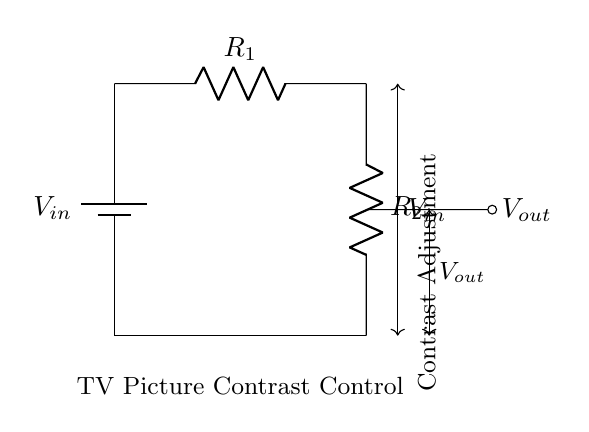What is the input voltage in the circuit? The input voltage, labeled as V_in, is the voltage supplied by the battery in the diagram.
Answer: V_in What are the two resistors used in this circuit? The circuit contains two resistors, labeled R_1 and R_2, which are essential for the voltage divider function.
Answer: R_1 and R_2 What is the output voltage taken from in this circuit? The output voltage, noted as V_out, is taken from the junction between R_1 and R_2, determined by the voltage divider formula.
Answer: V_out How do the resistors affect the picture contrast? Resistors R_1 and R_2 divide the input voltage to create the output voltage, which adjusts the picture contrast when applied to the TV circuitry.
Answer: Voltage division What is the function of this voltage divider circuit specifically? The function of this voltage divider circuit is to control the contrast of the TV picture by adjusting V_out according to the input voltage.
Answer: Contrast adjustment How does increasing R_1 affect the output voltage? Increasing R_1 will reduce V_out, since a larger resistance decreases the share of voltage across R_2, impacting the contrast.
Answer: Decreases V_out What is indicated by the label "Contrast Adjustment" in the diagram? The label signifies that the output voltage from this divider circuit is used to tailor the display settings specifically for picture contrast.
Answer: Picture contrast control 